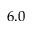<formula> <loc_0><loc_0><loc_500><loc_500>6 . 0</formula> 